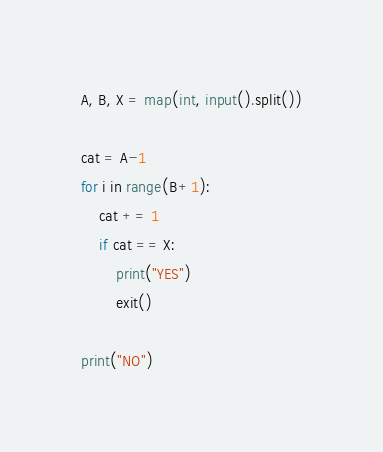<code> <loc_0><loc_0><loc_500><loc_500><_Python_>A, B, X = map(int, input().split())

cat = A-1
for i in range(B+1):
    cat += 1
    if cat == X:
        print("YES")
        exit()
        
print("NO")</code> 